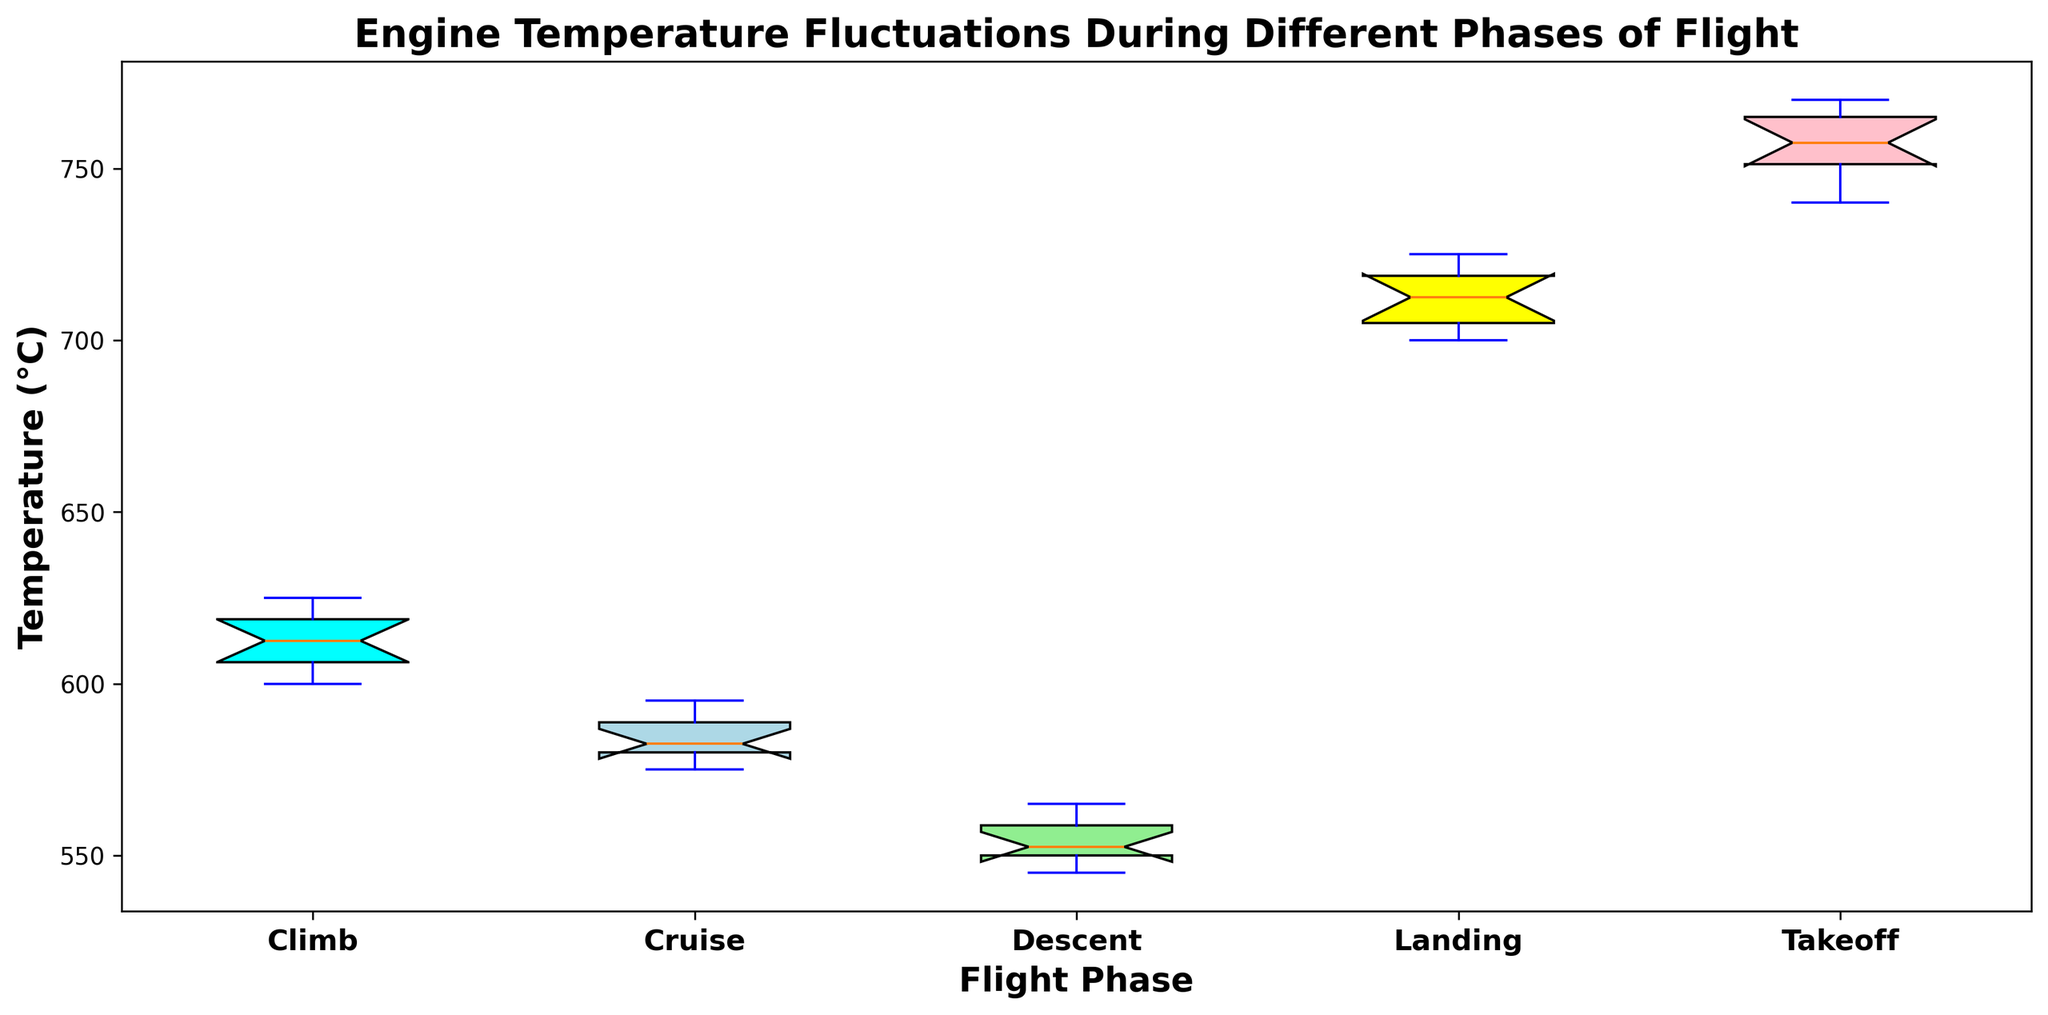What's the median temperature during the Climb phase? To find the median temperature during the Climb phase, observe the horizontal line inside the box for the Climb data. This line represents the median value.
Answer: 610°C Which phase has the highest median engine temperature? Look at the position of the horizontal line (median) within the boxes for all phases. The phase with the highest horizontal line indicates the highest median temperature.
Answer: Takeoff How does the interquartile range (IQR) of the Cruise phase compare to the Descent phase? The IQR is the range between the lower quartile (Q1, bottom edge of the box) and the upper quartile (Q3, top edge of the box). Visually compare the height of the boxes (IQRs) for Cruise and Descent. The boxes represent a similar height, indicating similar IQRs.
Answer: Similar IQRs Which phase has the smallest range of engine temperatures? The range is represented by the distance between the whiskers (ends of the vertical lines) of each box plot. Identify the shortest interval from whisker to whisker.
Answer: Descent What is the temperature range during Takeoff? Range is calculated as the maximum value minus the minimum value. Look at the upper and lower whiskers for the Takeoff phase. The range is 770°C - 740°C.
Answer: 30°C Which flight phase shows the most variability in engine temperature? Variability can be inferred from the length of the whiskers and the size of the box (IQR). The phase with the longest combined whiskers and box height indicates the most variability.
Answer: Takeoff Are there any outliers in the engine temperature data during any of the phases? Outliers are indicated by dots outside the range of the whiskers. Check for any such dots in the plot.
Answer: No outliers Which colored box represents the Cruise phase? Identify the color of each phase's box by matching it to the given colors. Cruise is often colored light green in this context.
Answer: Light green What’s the difference between the median temperatures of the Takeoff and Landing phases? Determine the medians for both phases by referring to the horizontal lines within the boxes, then calculate the difference (Takeoff median - Landing median). Medians are 755°C for Takeoff and 710°C for Landing. 755°C - 710°C = 45°C.
Answer: 45°C Which phase has the box plot with the most symmetric distribution? A symmetric distribution will have the median line (within the box) centered and the whiskers of approximately equal lengths. Identify the box plot that fits these criteria.
Answer: Cruise 